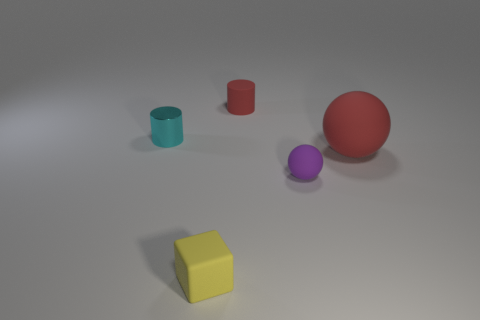There is a block that is the same size as the metallic cylinder; what is its color?
Keep it short and to the point. Yellow. What number of things are red matte cylinders or yellow cubes?
Your response must be concise. 2. What color is the small matte object right of the small red cylinder?
Provide a succinct answer. Purple. The other shiny object that is the same shape as the tiny red thing is what size?
Make the answer very short. Small. How many things are either tiny things left of the small purple matte ball or things that are behind the purple ball?
Keep it short and to the point. 4. What size is the rubber object that is on the left side of the big rubber ball and behind the small purple sphere?
Your answer should be compact. Small. There is a small cyan shiny object; does it have the same shape as the matte object that is to the right of the purple sphere?
Offer a very short reply. No. What number of objects are things that are left of the small rubber cylinder or small objects?
Your answer should be compact. 4. Does the tiny cyan thing have the same material as the cylinder to the right of the yellow block?
Your answer should be compact. No. What is the shape of the rubber object left of the small rubber thing behind the big thing?
Provide a succinct answer. Cube. 